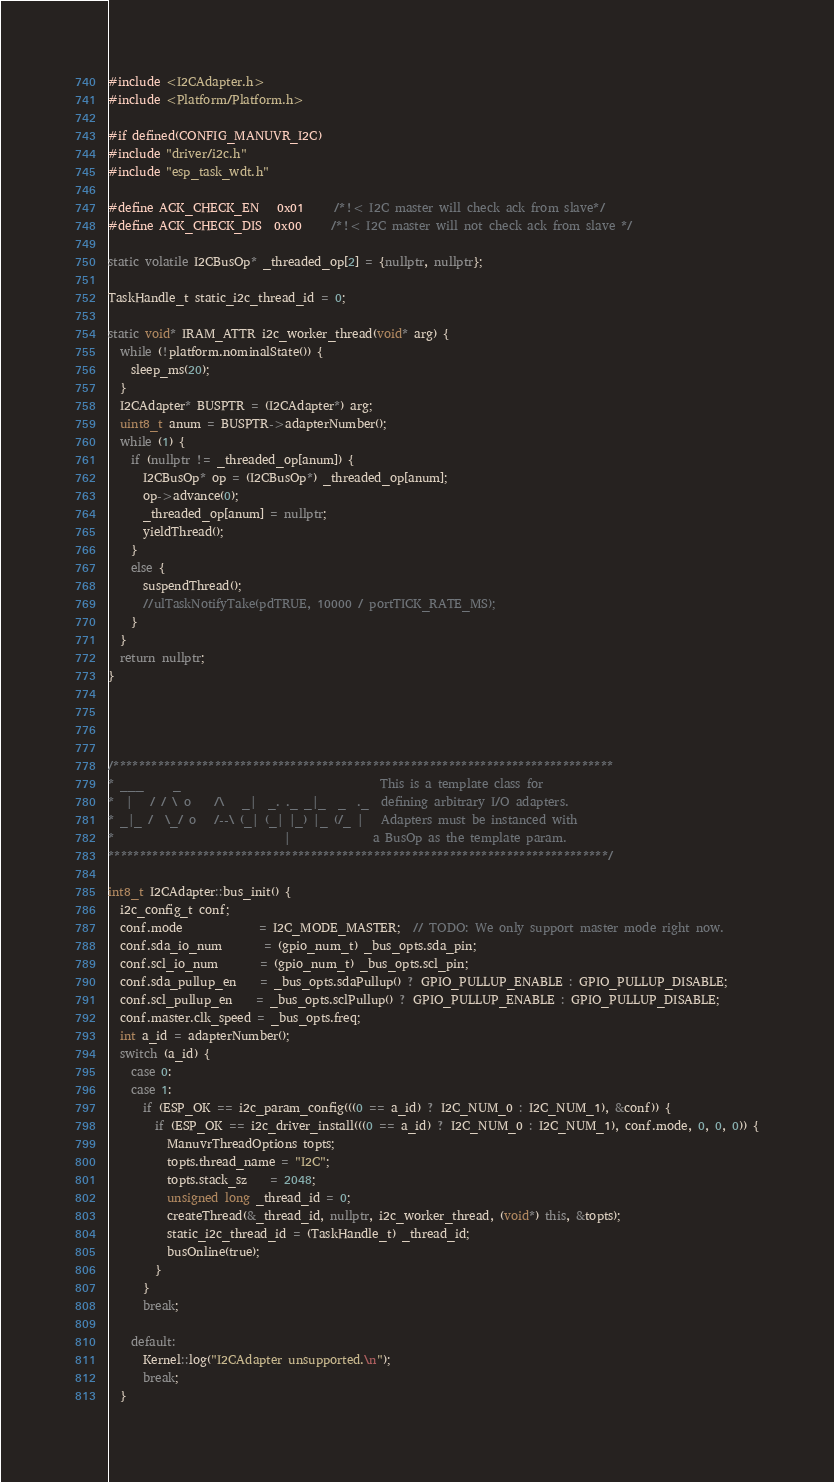Convert code to text. <code><loc_0><loc_0><loc_500><loc_500><_C++_>#include <I2CAdapter.h>
#include <Platform/Platform.h>

#if defined(CONFIG_MANUVR_I2C)
#include "driver/i2c.h"
#include "esp_task_wdt.h"

#define ACK_CHECK_EN   0x01     /*!< I2C master will check ack from slave*/
#define ACK_CHECK_DIS  0x00     /*!< I2C master will not check ack from slave */

static volatile I2CBusOp* _threaded_op[2] = {nullptr, nullptr};

TaskHandle_t static_i2c_thread_id = 0;

static void* IRAM_ATTR i2c_worker_thread(void* arg) {
  while (!platform.nominalState()) {
    sleep_ms(20);
  }
  I2CAdapter* BUSPTR = (I2CAdapter*) arg;
  uint8_t anum = BUSPTR->adapterNumber();
  while (1) {
    if (nullptr != _threaded_op[anum]) {
      I2CBusOp* op = (I2CBusOp*) _threaded_op[anum];
      op->advance(0);
      _threaded_op[anum] = nullptr;
      yieldThread();
    }
    else {
      suspendThread();
      //ulTaskNotifyTake(pdTRUE, 10000 / portTICK_RATE_MS);
    }
  }
  return nullptr;
}




/*******************************************************************************
* ___     _                                  This is a template class for
*  |   / / \ o    /\   _|  _. ._ _|_  _  ._  defining arbitrary I/O adapters.
* _|_ /  \_/ o   /--\ (_| (_| |_) |_ (/_ |   Adapters must be instanced with
*                             |              a BusOp as the template param.
*******************************************************************************/

int8_t I2CAdapter::bus_init() {
  i2c_config_t conf;
  conf.mode             = I2C_MODE_MASTER;  // TODO: We only support master mode right now.
  conf.sda_io_num       = (gpio_num_t) _bus_opts.sda_pin;
  conf.scl_io_num       = (gpio_num_t) _bus_opts.scl_pin;
  conf.sda_pullup_en    = _bus_opts.sdaPullup() ? GPIO_PULLUP_ENABLE : GPIO_PULLUP_DISABLE;
  conf.scl_pullup_en    = _bus_opts.sclPullup() ? GPIO_PULLUP_ENABLE : GPIO_PULLUP_DISABLE;
  conf.master.clk_speed = _bus_opts.freq;
  int a_id = adapterNumber();
  switch (a_id) {
    case 0:
    case 1:
      if (ESP_OK == i2c_param_config(((0 == a_id) ? I2C_NUM_0 : I2C_NUM_1), &conf)) {
        if (ESP_OK == i2c_driver_install(((0 == a_id) ? I2C_NUM_0 : I2C_NUM_1), conf.mode, 0, 0, 0)) {
          ManuvrThreadOptions topts;
          topts.thread_name = "I2C";
          topts.stack_sz    = 2048;
          unsigned long _thread_id = 0;
          createThread(&_thread_id, nullptr, i2c_worker_thread, (void*) this, &topts);
          static_i2c_thread_id = (TaskHandle_t) _thread_id;
          busOnline(true);
        }
      }
      break;

    default:
      Kernel::log("I2CAdapter unsupported.\n");
      break;
  }</code> 